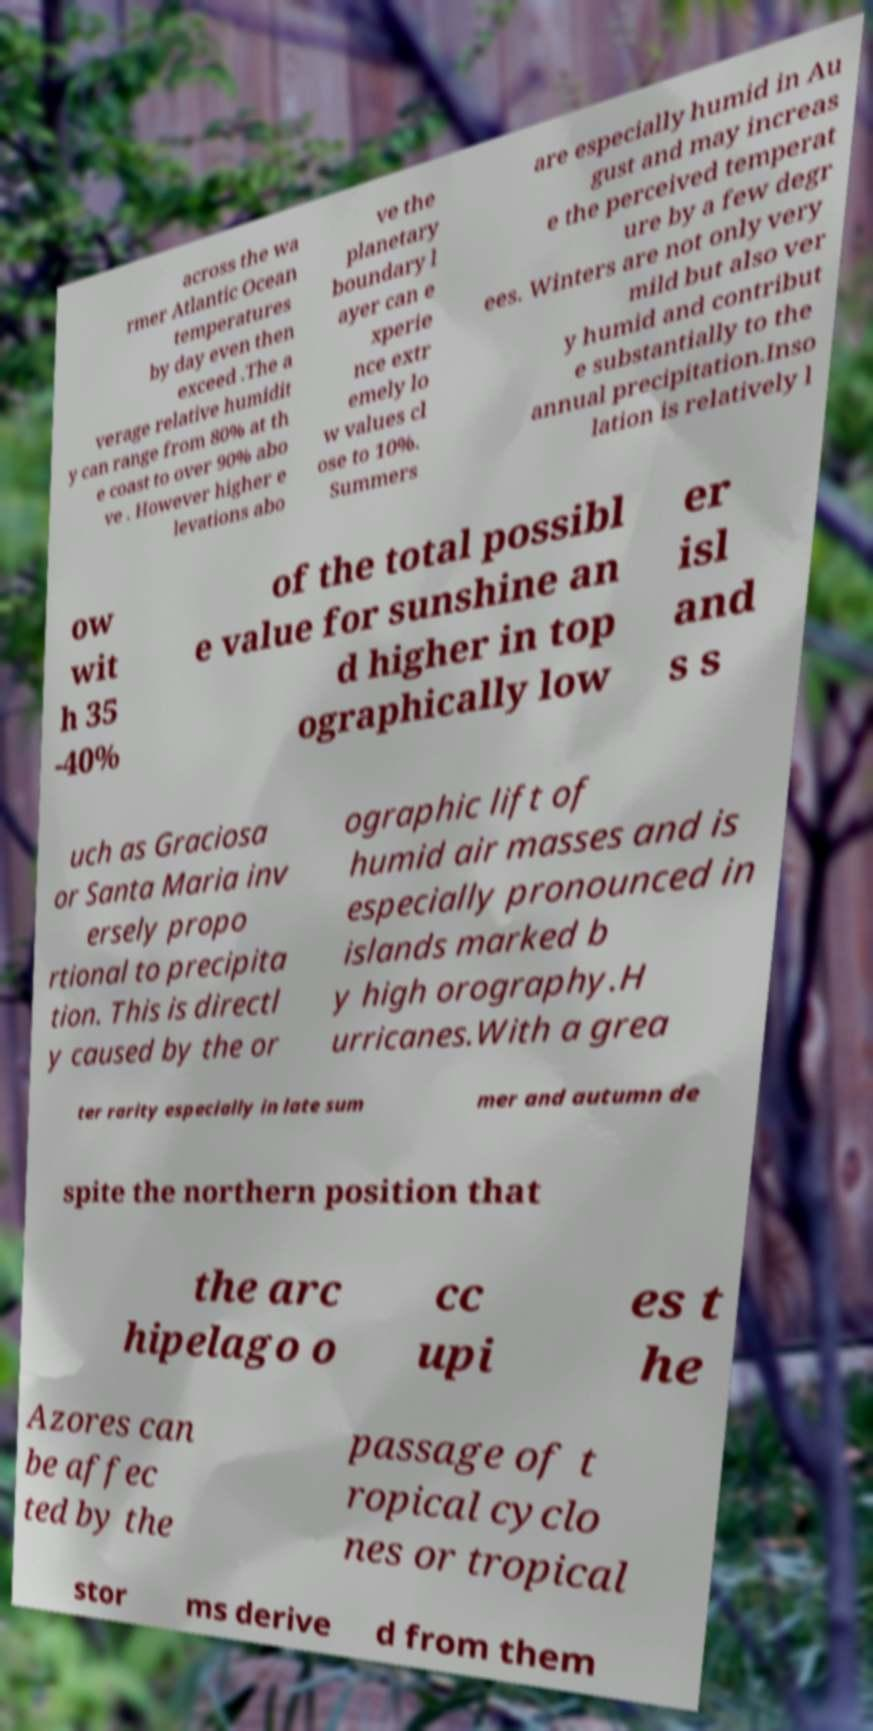What messages or text are displayed in this image? I need them in a readable, typed format. across the wa rmer Atlantic Ocean temperatures by day even then exceed .The a verage relative humidit y can range from 80% at th e coast to over 90% abo ve . However higher e levations abo ve the planetary boundary l ayer can e xperie nce extr emely lo w values cl ose to 10%. Summers are especially humid in Au gust and may increas e the perceived temperat ure by a few degr ees. Winters are not only very mild but also ver y humid and contribut e substantially to the annual precipitation.Inso lation is relatively l ow wit h 35 -40% of the total possibl e value for sunshine an d higher in top ographically low er isl and s s uch as Graciosa or Santa Maria inv ersely propo rtional to precipita tion. This is directl y caused by the or ographic lift of humid air masses and is especially pronounced in islands marked b y high orography.H urricanes.With a grea ter rarity especially in late sum mer and autumn de spite the northern position that the arc hipelago o cc upi es t he Azores can be affec ted by the passage of t ropical cyclo nes or tropical stor ms derive d from them 